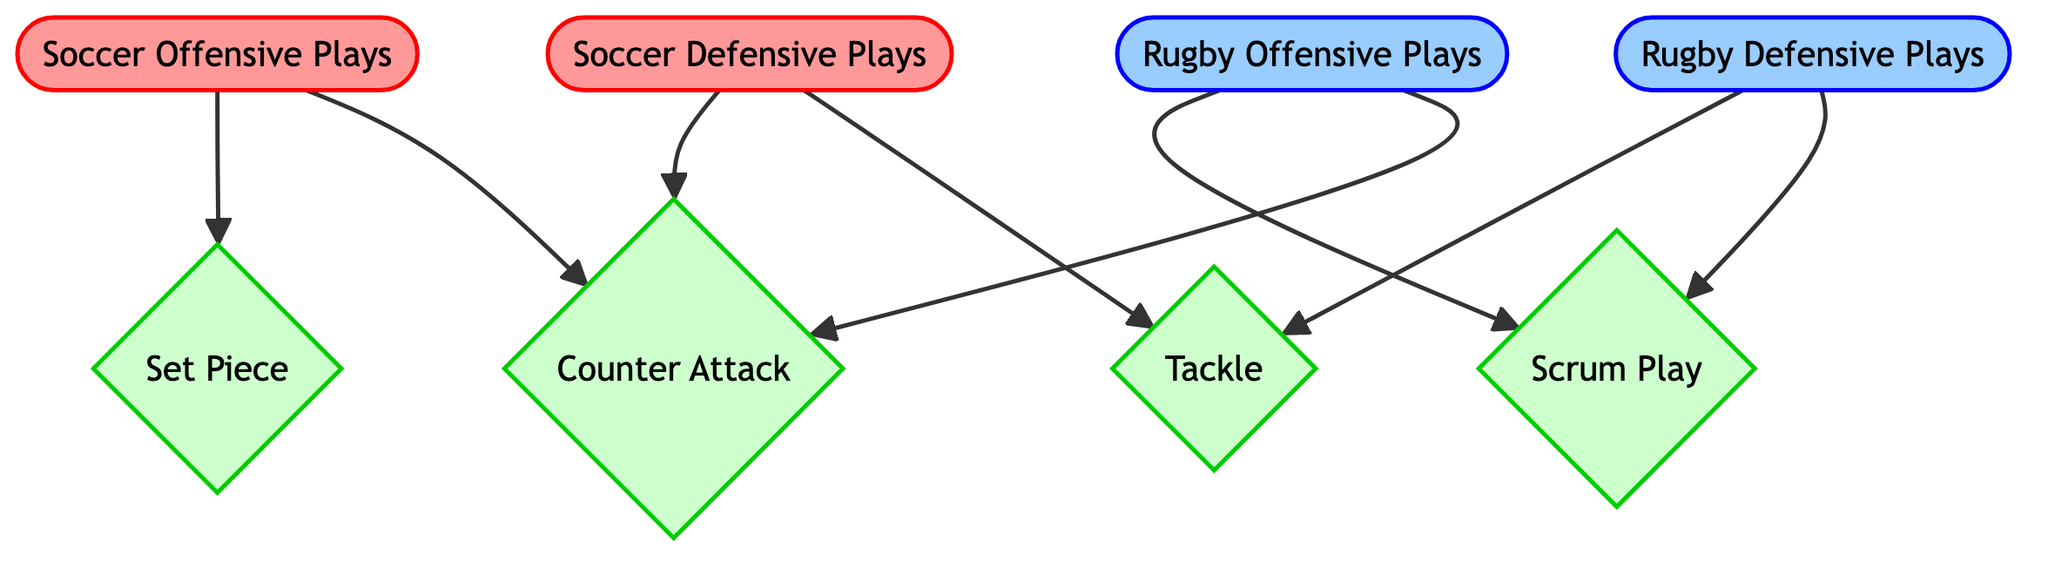What are the two types of offensive plays in soccer? The diagram indicates that the two types of offensive plays in soccer are "Set Piece" and "Counter Attack," both stemming from the "Soccer Offensive Plays" node.
Answer: Set Piece, Counter Attack How many defensive plays are there in rugby? The diagram shows that there is one defensive play indicated by the "Rugby Defensive Plays" node, which connects to "Tackle" and "Scrum," making a total of two defensive plays.
Answer: Tackle, Scrum What play is a common feature in both soccer and rugby? The "Counter Attack" node appears as an outcome of both offensive plays in soccer and rugby, indicating it is a common play between the two sports.
Answer: Counter Attack Which play is associated with both soccer and rugby defense? The "Tackle" play is connected to both "Soccer Defensive Plays" and "Rugby Defensive Plays," indicating it is a defense-related play common to both sports.
Answer: Tackle How many total nodes are in the diagram? There are eight nodes listed in the diagram, which include "Soccer Offensive Plays," "Soccer Defensive Plays," "Rugby Offensive Plays," "Rugby Defensive Plays," "Counter Attack," "Set Piece," "Scrum Play," and "Tackle."
Answer: 8 Which offensive play leads to a scrum in rugby? The diagram shows that "Rugby Offensive Plays" connects directly to "Scrum," indicating it leads to a scrum in rugby.
Answer: Scrum 